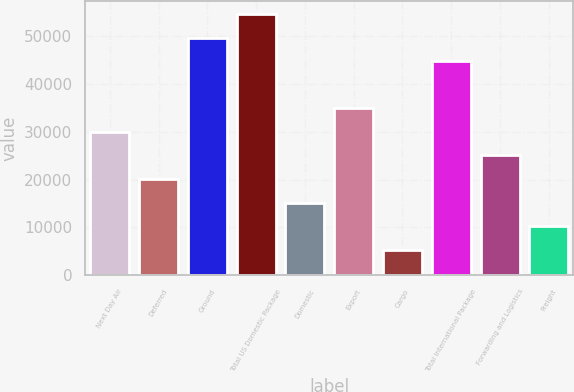Convert chart. <chart><loc_0><loc_0><loc_500><loc_500><bar_chart><fcel>Next Day Air<fcel>Deferred<fcel>Ground<fcel>Total US Domestic Package<fcel>Domestic<fcel>Export<fcel>Cargo<fcel>Total International Package<fcel>Forwarding and Logistics<fcel>Freight<nl><fcel>29978<fcel>20121<fcel>49692<fcel>54620.5<fcel>15192.5<fcel>34906.5<fcel>5335.5<fcel>44763.5<fcel>25049.5<fcel>10264<nl></chart> 